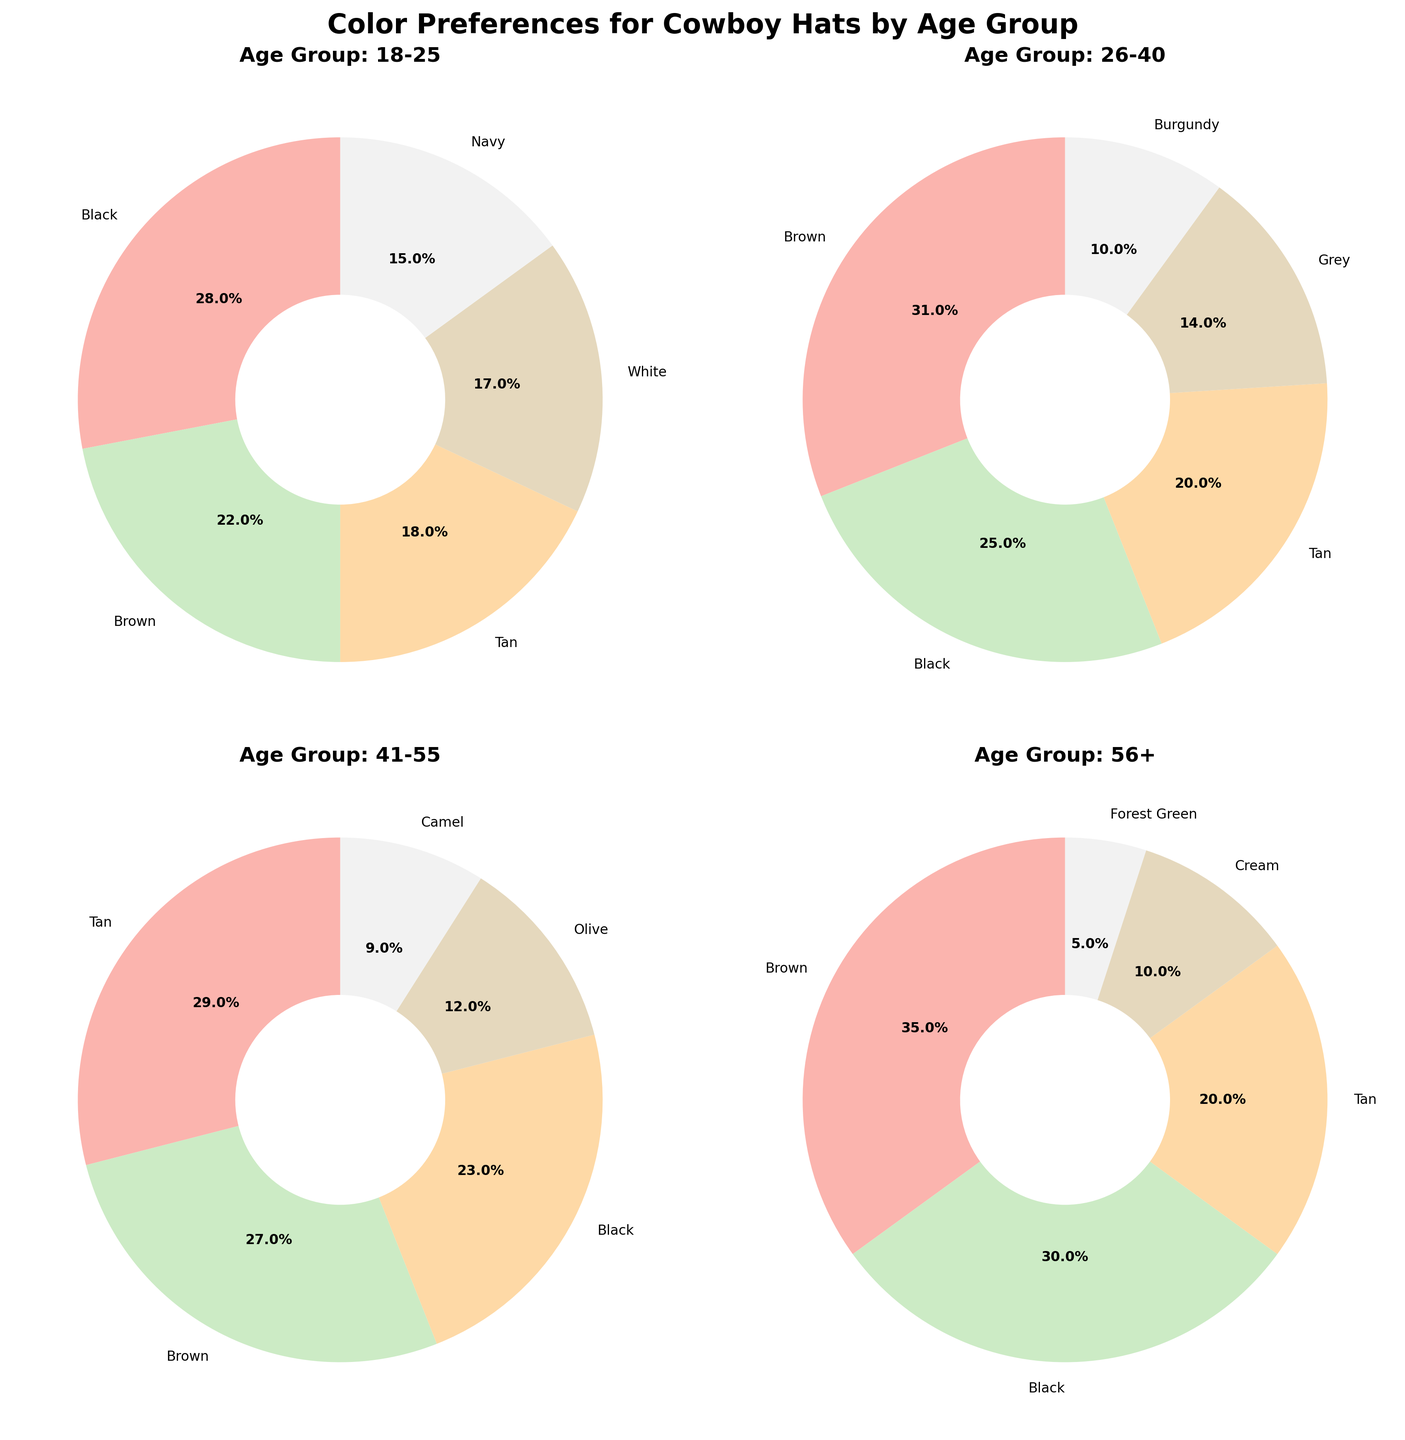What color preference dominates the 18-25 age group? The pie chart for the 18-25 age group shows that the segment representing 'Black' is the largest, indicating it is the dominant color preference.
Answer: Black Which age group has the highest percentage preference for Brown hats? We examine each pie chart: 18-25 has 22%, 26-40 has 31%, 41-55 has 27%, and 56+ has 35%. The highest percentage is 56+.
Answer: 56+ What is the total preference percentage for Tan and Black combined in the 18-25 age group? In the 18-25 age group, Tan is 18% and Black is 28%. Adding these together: 18% + 28% = 46%.
Answer: 46% Compare the preference for Grey in the 26-40 age group versus Olive in the 41-55 age group. Which is higher? In the pie charts, Grey in 26-40 is 14% and Olive in 41-55 is 12%. Grey has a higher preference than Olive.
Answer: Grey What is the difference in percentage preference for Black hats between the 18-25 and 41-55 age groups? In the pie charts, Black in 18-25 is 28%, and in 41-55 it is 23%. The difference is 28% - 23% = 5%.
Answer: 5% Which age group shows the least diversity in color preferences? The least diversity is seen where one color has a significantly larger slice. In 56+, Brown (35%) and Black (30%) dominate, leading to less diversity.
Answer: 56+ Is White a more popular color for the 18-25 or 56+ group? Comparing the charts, White is a preference in 18-25 with 17%, but not present in the chart for 56+, indicating it is more popular among 18-25.
Answer: 18-25 What's the combined percentage preference for the top two colors in the 41-55 age group? The top two colors in 41-55 are Tan (29%) and Brown (27%). Adding them: 29% + 27% = 56%.
Answer: 56% How does the preference for Camel in 41-55 compare to Forest Green in 56+? From the charts, Camel in 41-55 is 9%, and Forest Green in 56+ is 5%. Camel has a higher preference than Forest Green.
Answer: Camel Which age group has the closest distribution of preferences among the top five colors? The 18-25 group has a closer distribution among the top five (Black 28%, Brown 22%, Tan 18%, White 17%, Navy 15%), indicating relatively even preferences.
Answer: 18-25 